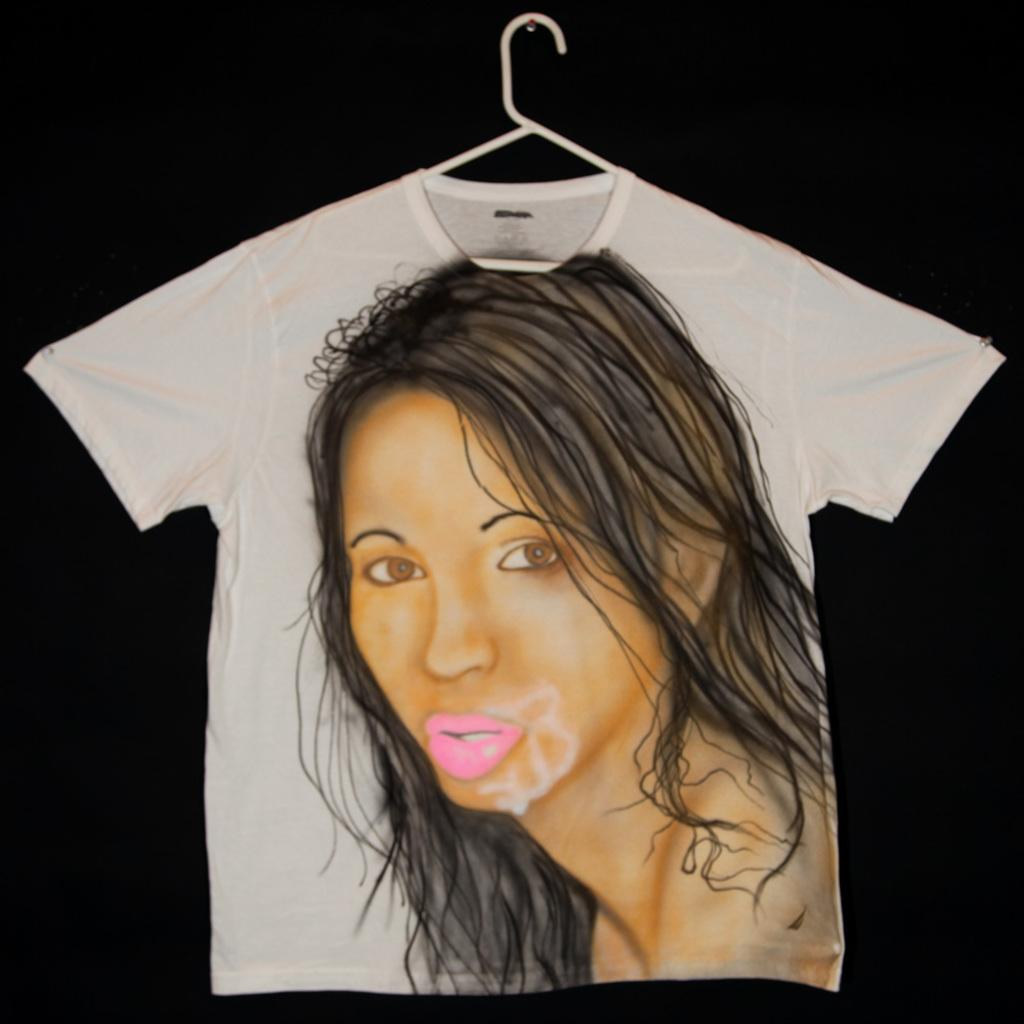What type of clothing item is visible in the image? There is a T-shirt in the image. What is depicted on the T-shirt? The T-shirt has an image of a lady on it. What color is the background of the image? The background of the image is black in color. How many sticks are used to create the image of the lady on the T-shirt? There are no sticks used to create the image of the lady on the T-shirt; it is a printed design. What type of seafood is present in the image? There is no seafood present in the image; it features a T-shirt with an image of a lady. 